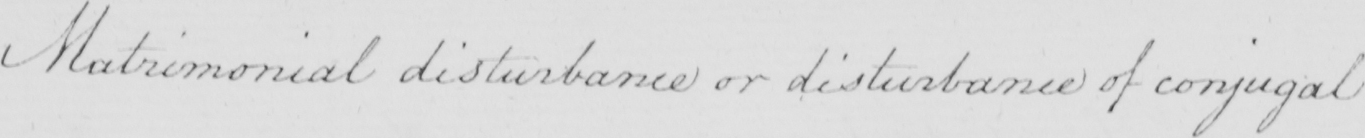What is written in this line of handwriting? Matrimonial disturbance or disturbance of conjugal 